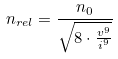Convert formula to latex. <formula><loc_0><loc_0><loc_500><loc_500>n _ { r e l } = \frac { n _ { 0 } } { \sqrt { 8 \cdot \frac { v ^ { 9 } } { i ^ { 9 } } } }</formula> 